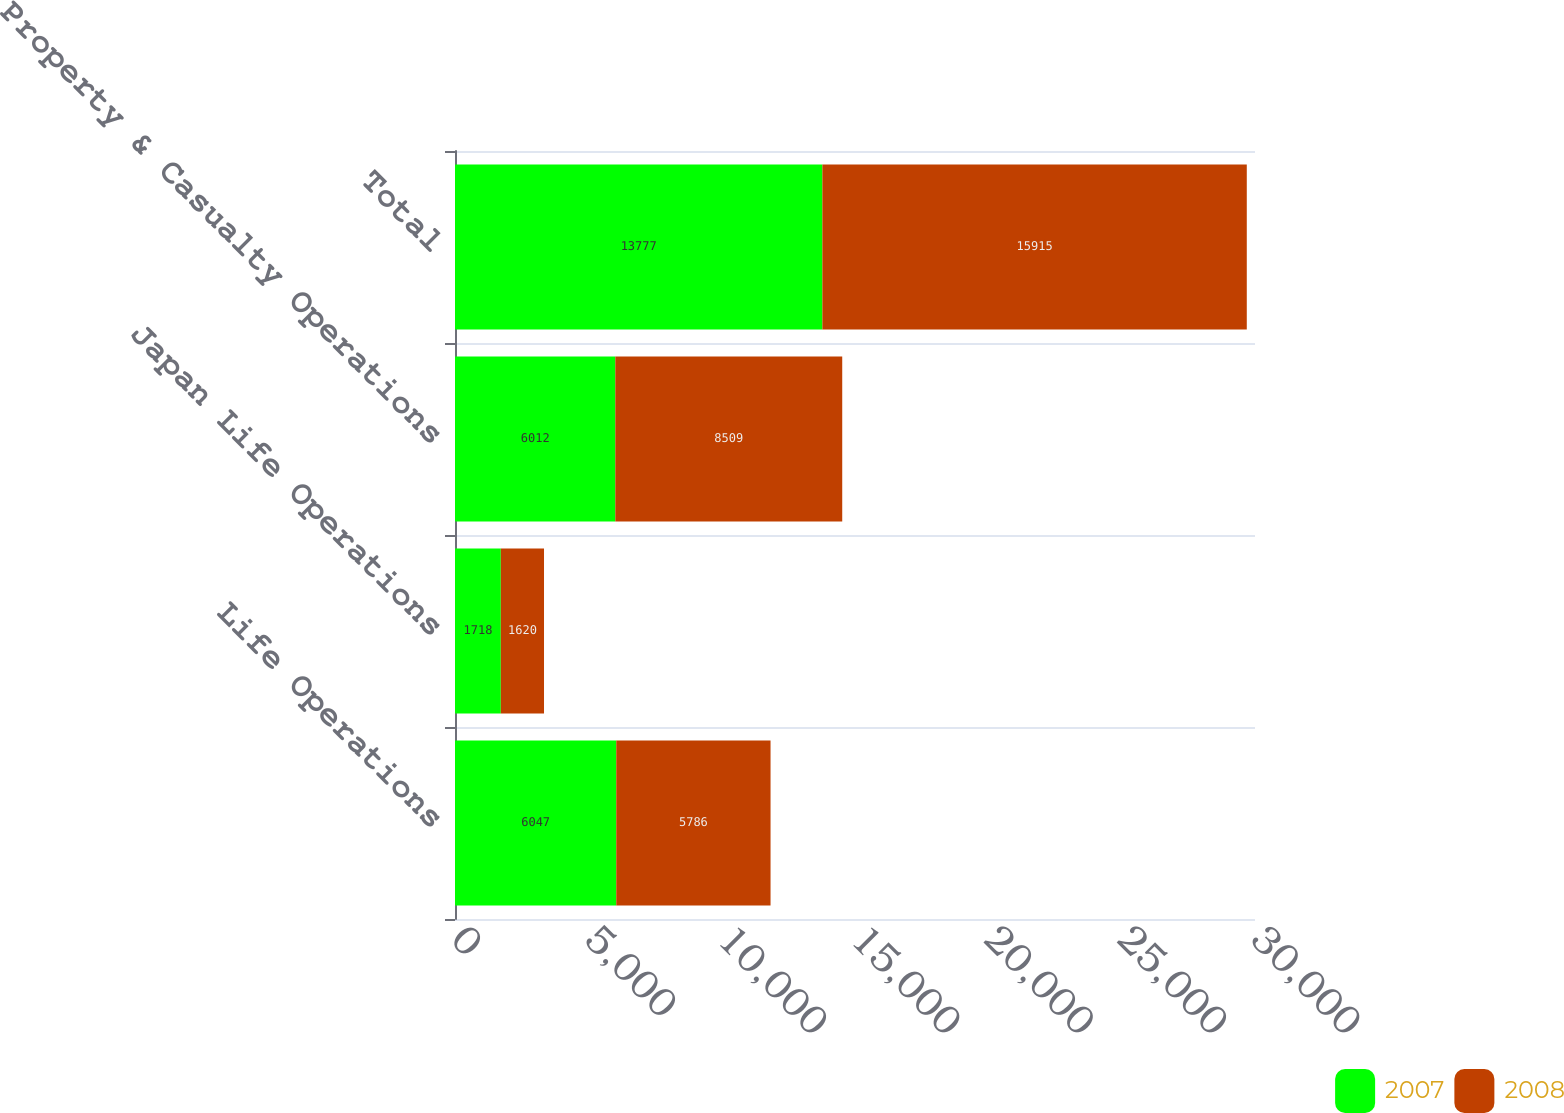Convert chart. <chart><loc_0><loc_0><loc_500><loc_500><stacked_bar_chart><ecel><fcel>Life Operations<fcel>Japan Life Operations<fcel>Property & Casualty Operations<fcel>Total<nl><fcel>2007<fcel>6047<fcel>1718<fcel>6012<fcel>13777<nl><fcel>2008<fcel>5786<fcel>1620<fcel>8509<fcel>15915<nl></chart> 